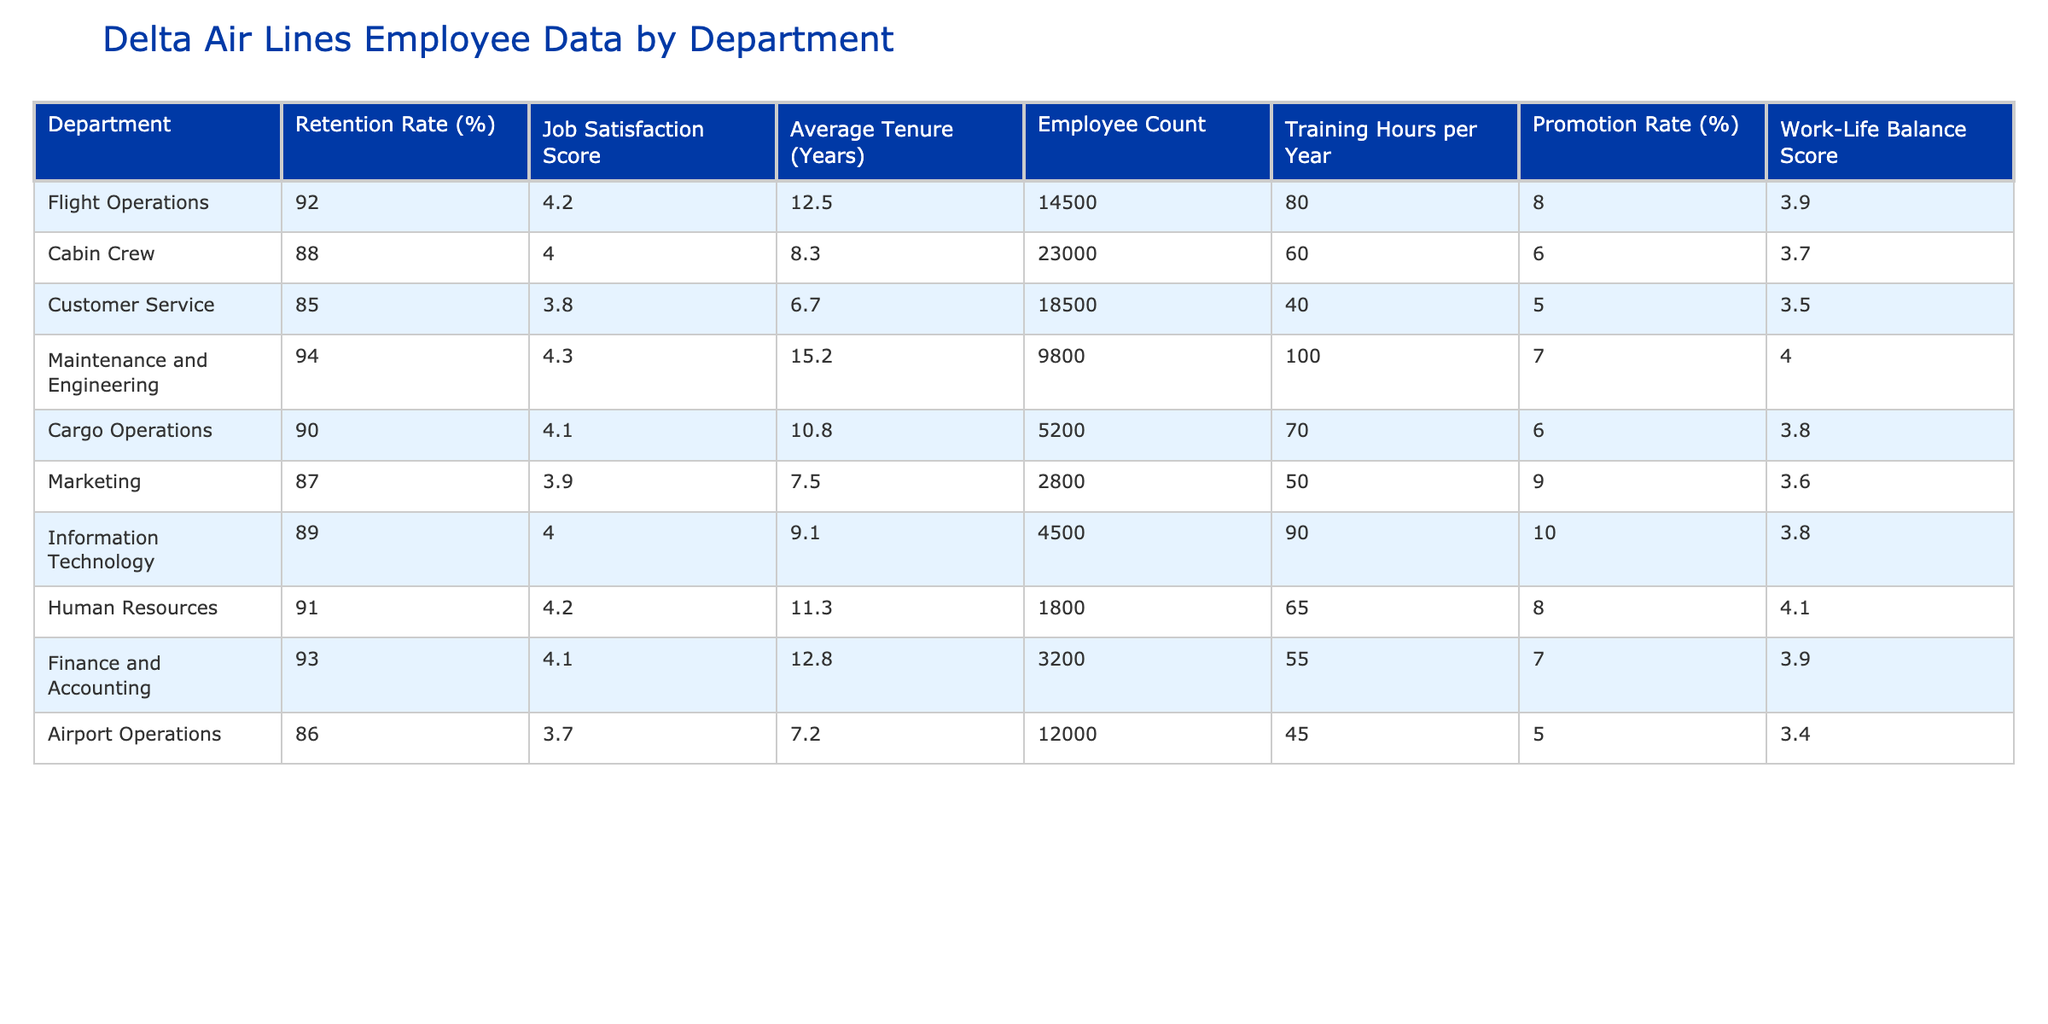What is the retention rate for the Cabin Crew department? The table lists the retention rate percentage for each department. For Cabin Crew, the retention rate is provided as 88%.
Answer: 88% Which department has the highest job satisfaction score? By comparing the Job Satisfaction Score across all departments in the table, Maintenance and Engineering has the highest score at 4.3.
Answer: 4.3 What is the average tenure of employees in Flight Operations? The table directly states the Average Tenure for Flight Operations as 12.5 years.
Answer: 12.5 years Which department has the lowest work-life balance score? The Work-Life Balance Score for each department is listed, and Airport Operations has the lowest score of 3.4.
Answer: 3.4 Calculate the average job satisfaction score across all departments. To calculate the average, sum all the job satisfaction scores (4.2 + 4.0 + 3.8 + 4.3 + 4.1 + 3.9 + 4.0 + 4.2 + 4.1 + 3.7) = 40.3, and divide by the number of departments (10), resulting in an average of 4.03.
Answer: 4.03 Is the promotion rate in Maintenance and Engineering higher than in Customer Service? The promotion rates are 7% for Maintenance and Engineering and 5% for Customer Service. Since 7% is greater than 5%, the statement is true.
Answer: Yes How does the training hours per year in Information Technology compare to that in Marketing? Information Technology has 90 training hours per year and Marketing has 50. Since 90 is greater than 50, IT has more training hours.
Answer: More What is the total employee count across all departments? To find the total employee count, sum the counts from all departments: (14500 + 23000 + 18500 + 9800 + 5200 + 2800 + 4500 + 1800 + 3200 + 12000) = 109300.
Answer: 109300 Which department has a higher retention rate: Cargo Operations or Customer Service? Cargo Operations has a retention rate of 90%, while Customer Service has 85%. Since 90% is greater than 85%, Cargo Operations has the higher retention rate.
Answer: Cargo Operations If an employee from the Cabin Crew department has 60 training hours per year, which department exceeds this number by the most training hours? The department with the highest training hours is Maintenance and Engineering with 100 hours, exceeding Cabin Crew's 60 hours by 40 hours (100 - 60 = 40).
Answer: Maintenance and Engineering 